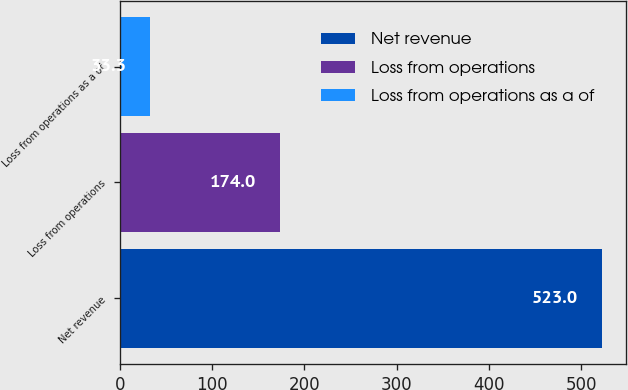Convert chart. <chart><loc_0><loc_0><loc_500><loc_500><bar_chart><fcel>Net revenue<fcel>Loss from operations<fcel>Loss from operations as a of<nl><fcel>523<fcel>174<fcel>33.3<nl></chart> 